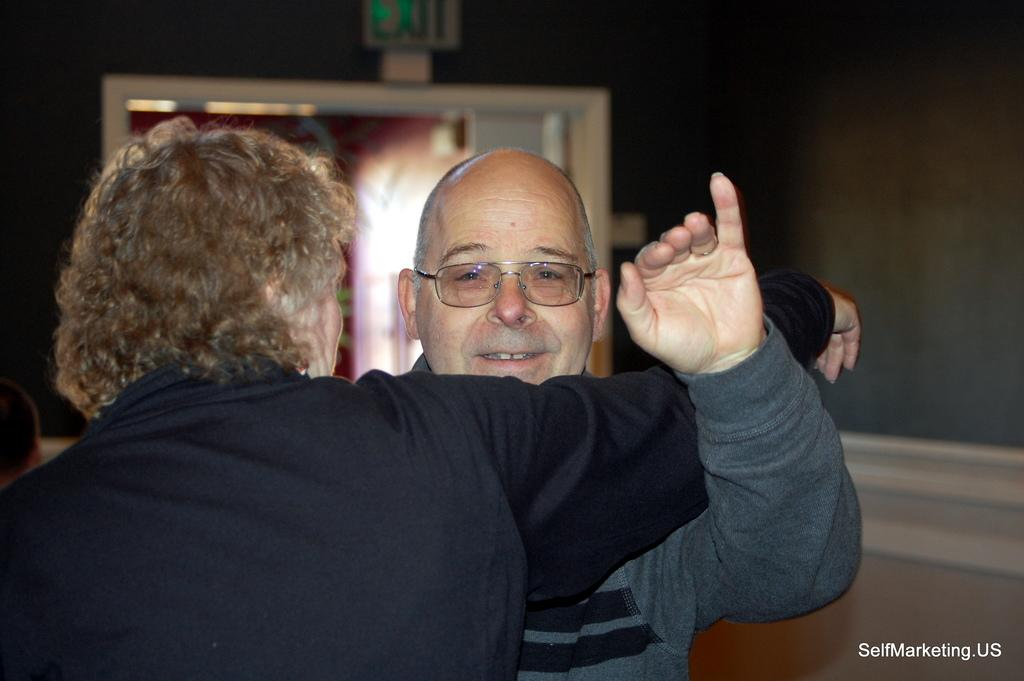How many people are in the image? There are two persons in the image. What color shirt is the person in front wearing? The person in front is wearing a black color shirt. Can you describe the objects in the background of the image? The objects in the background have white and gray colors. Is the dog in the image sneezing? There is no dog present in the image, so it cannot be determined if it is sneezing or not. 